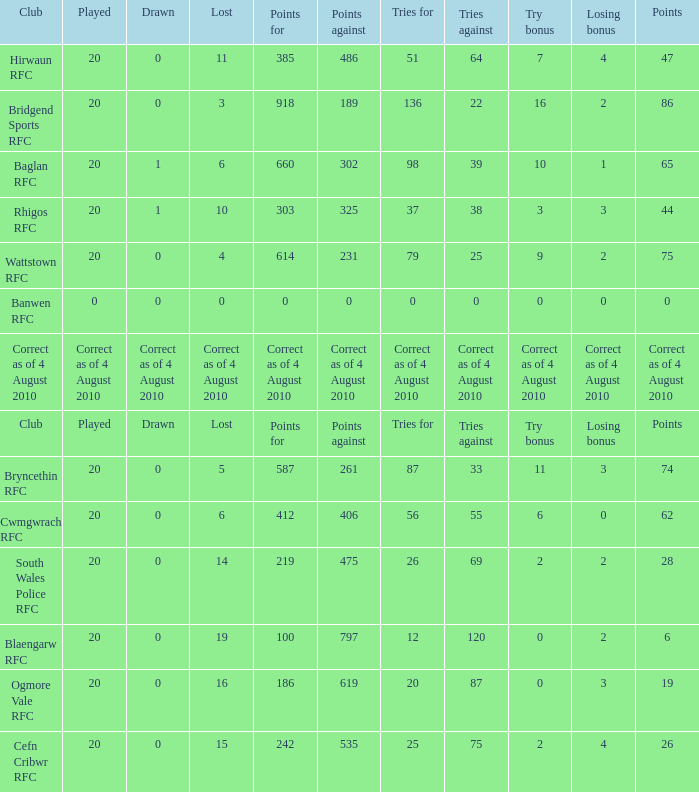What is the tries fow when losing bonus is losing bonus? Tries for. 